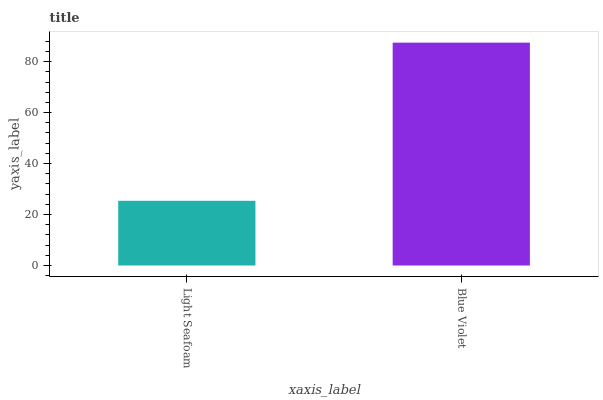Is Light Seafoam the minimum?
Answer yes or no. Yes. Is Blue Violet the maximum?
Answer yes or no. Yes. Is Blue Violet the minimum?
Answer yes or no. No. Is Blue Violet greater than Light Seafoam?
Answer yes or no. Yes. Is Light Seafoam less than Blue Violet?
Answer yes or no. Yes. Is Light Seafoam greater than Blue Violet?
Answer yes or no. No. Is Blue Violet less than Light Seafoam?
Answer yes or no. No. Is Blue Violet the high median?
Answer yes or no. Yes. Is Light Seafoam the low median?
Answer yes or no. Yes. Is Light Seafoam the high median?
Answer yes or no. No. Is Blue Violet the low median?
Answer yes or no. No. 